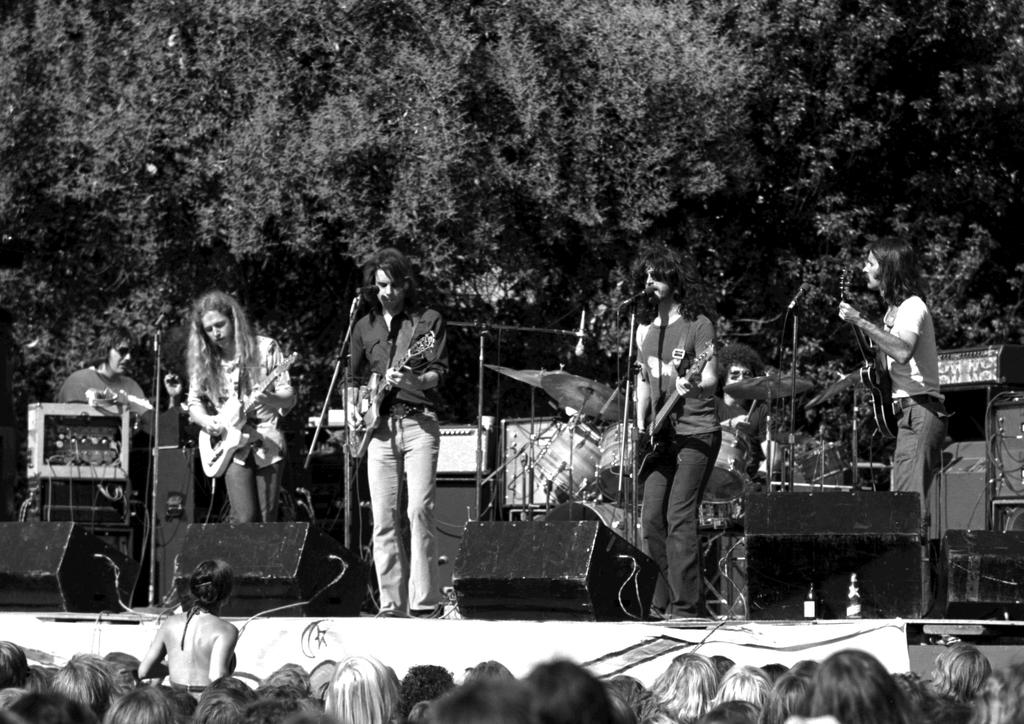How many people are playing a guitar in the image? There are four people playing a guitar in the image. What are the four people doing in the middle of the image? The four people are playing a guitar. Can you describe the person located to the left of the image? There is a person to the left of the image, but no specific details are provided about this person. What is the audience doing in the image? The audience is watching the performance of the four people playing a guitar. How many bikes are parked in front of the audience in the image? There is no mention of bikes in the image; it only describes a performance with four people playing a guitar and an audience watching them. Can you describe the chair that the duck is sitting on in the image? There is no mention of a chair or a duck in the image. 